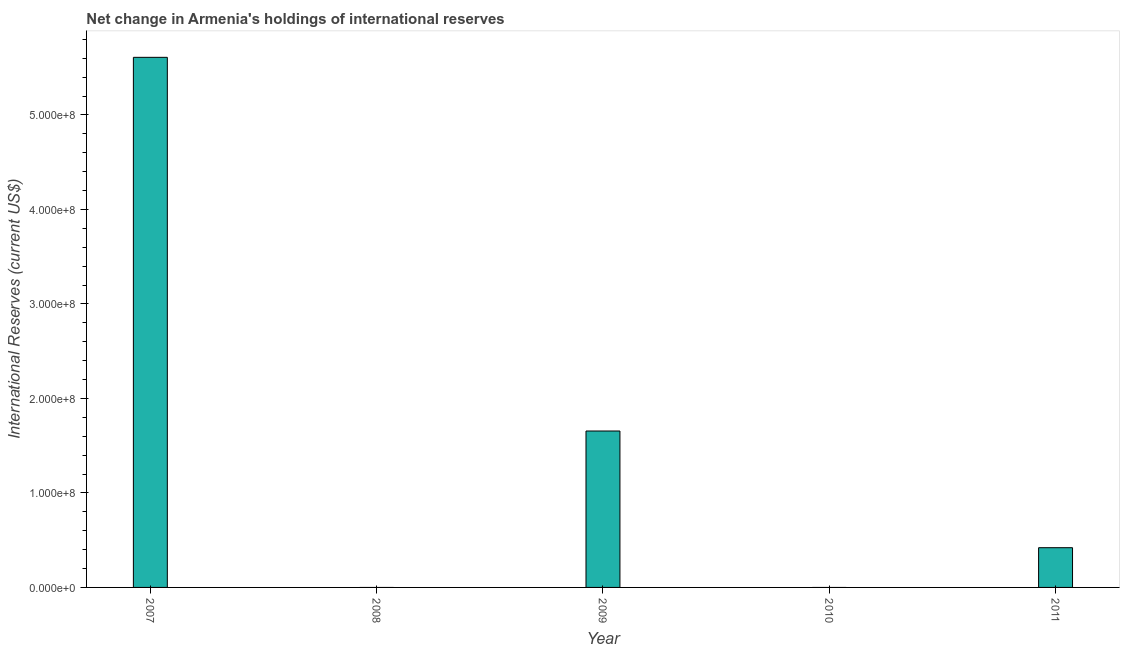Does the graph contain any zero values?
Offer a very short reply. Yes. What is the title of the graph?
Offer a very short reply. Net change in Armenia's holdings of international reserves. What is the label or title of the Y-axis?
Ensure brevity in your answer.  International Reserves (current US$). What is the reserves and related items in 2011?
Your answer should be compact. 4.20e+07. Across all years, what is the maximum reserves and related items?
Your response must be concise. 5.61e+08. What is the sum of the reserves and related items?
Your response must be concise. 7.68e+08. What is the difference between the reserves and related items in 2009 and 2011?
Make the answer very short. 1.23e+08. What is the average reserves and related items per year?
Offer a very short reply. 1.54e+08. What is the median reserves and related items?
Ensure brevity in your answer.  4.20e+07. In how many years, is the reserves and related items greater than 180000000 US$?
Your answer should be compact. 1. What is the ratio of the reserves and related items in 2009 to that in 2011?
Provide a short and direct response. 3.94. What is the difference between the highest and the second highest reserves and related items?
Your answer should be compact. 3.95e+08. Is the sum of the reserves and related items in 2009 and 2011 greater than the maximum reserves and related items across all years?
Make the answer very short. No. What is the difference between the highest and the lowest reserves and related items?
Keep it short and to the point. 5.61e+08. In how many years, is the reserves and related items greater than the average reserves and related items taken over all years?
Your answer should be compact. 2. How many years are there in the graph?
Keep it short and to the point. 5. What is the difference between two consecutive major ticks on the Y-axis?
Give a very brief answer. 1.00e+08. Are the values on the major ticks of Y-axis written in scientific E-notation?
Provide a short and direct response. Yes. What is the International Reserves (current US$) in 2007?
Your answer should be compact. 5.61e+08. What is the International Reserves (current US$) of 2009?
Provide a short and direct response. 1.66e+08. What is the International Reserves (current US$) in 2010?
Ensure brevity in your answer.  0. What is the International Reserves (current US$) in 2011?
Make the answer very short. 4.20e+07. What is the difference between the International Reserves (current US$) in 2007 and 2009?
Offer a terse response. 3.95e+08. What is the difference between the International Reserves (current US$) in 2007 and 2011?
Make the answer very short. 5.19e+08. What is the difference between the International Reserves (current US$) in 2009 and 2011?
Your answer should be very brief. 1.23e+08. What is the ratio of the International Reserves (current US$) in 2007 to that in 2009?
Make the answer very short. 3.39. What is the ratio of the International Reserves (current US$) in 2007 to that in 2011?
Your response must be concise. 13.35. What is the ratio of the International Reserves (current US$) in 2009 to that in 2011?
Provide a succinct answer. 3.94. 